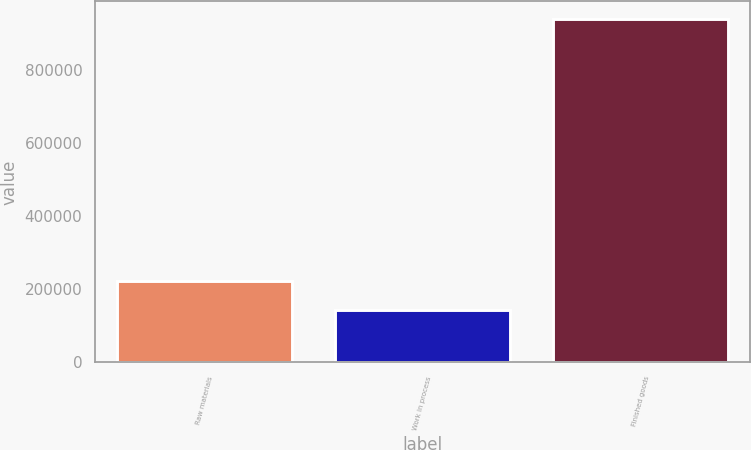Convert chart to OTSL. <chart><loc_0><loc_0><loc_500><loc_500><bar_chart><fcel>Raw materials<fcel>Work in process<fcel>Finished goods<nl><fcel>223496<fcel>143713<fcel>941540<nl></chart> 